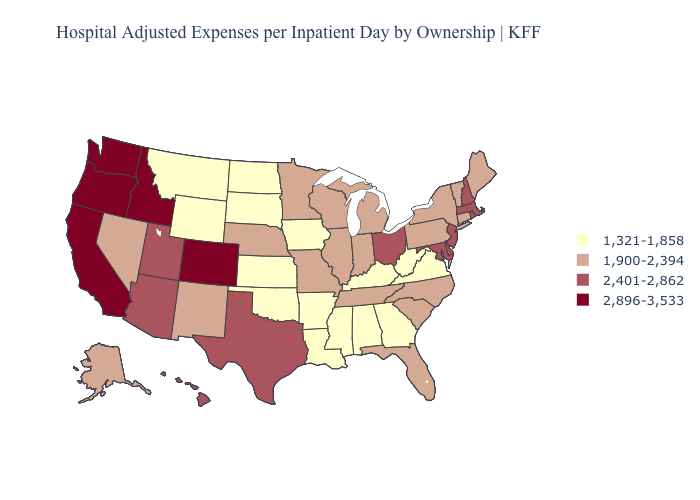Does Illinois have the same value as Delaware?
Be succinct. No. What is the value of Arizona?
Concise answer only. 2,401-2,862. Does North Carolina have the highest value in the USA?
Write a very short answer. No. Among the states that border Illinois , which have the highest value?
Answer briefly. Indiana, Missouri, Wisconsin. Which states have the lowest value in the Northeast?
Short answer required. Connecticut, Maine, New York, Pennsylvania, Vermont. What is the lowest value in the MidWest?
Give a very brief answer. 1,321-1,858. Does the map have missing data?
Answer briefly. No. What is the highest value in states that border Kansas?
Write a very short answer. 2,896-3,533. What is the value of Oklahoma?
Be succinct. 1,321-1,858. Which states have the highest value in the USA?
Keep it brief. California, Colorado, Idaho, Oregon, Washington. Which states have the lowest value in the MidWest?
Answer briefly. Iowa, Kansas, North Dakota, South Dakota. Does Illinois have the lowest value in the MidWest?
Short answer required. No. What is the value of Alabama?
Be succinct. 1,321-1,858. Name the states that have a value in the range 2,401-2,862?
Concise answer only. Arizona, Delaware, Hawaii, Maryland, Massachusetts, New Hampshire, New Jersey, Ohio, Rhode Island, Texas, Utah. Which states hav the highest value in the West?
Give a very brief answer. California, Colorado, Idaho, Oregon, Washington. 